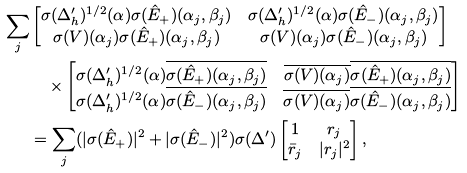Convert formula to latex. <formula><loc_0><loc_0><loc_500><loc_500>\sum _ { j } & \begin{bmatrix} \sigma ( \Delta ^ { \prime } _ { h } ) ^ { 1 / 2 } ( \alpha ) \sigma ( \hat { E } _ { + } ) ( \alpha _ { j } , \beta _ { j } ) & \sigma ( \Delta ^ { \prime } _ { h } ) ^ { 1 / 2 } ( \alpha ) \sigma ( \hat { E } _ { - } ) ( \alpha _ { j } , \beta _ { j } ) \\ \sigma ( V ) ( \alpha _ { j } ) \sigma ( \hat { E } _ { + } ) ( \alpha _ { j } , \beta _ { j } ) & \sigma ( V ) ( \alpha _ { j } ) \sigma ( \hat { E } _ { - } ) ( \alpha _ { j } , \beta _ { j } ) \end{bmatrix} \\ & \quad \times \begin{bmatrix} \sigma ( \Delta ^ { \prime } _ { h } ) ^ { 1 / 2 } ( \alpha ) \overline { \sigma ( \hat { E } _ { + } ) ( \alpha _ { j } , \beta _ { j } ) } & \overline { \sigma ( V ) ( \alpha _ { j } ) } \overline { \sigma ( \hat { E } _ { + } ) ( \alpha _ { j } , \beta _ { j } ) } \\ \sigma ( \Delta ^ { \prime } _ { h } ) ^ { 1 / 2 } ( \alpha ) \overline { \sigma ( \hat { E } _ { - } ) ( \alpha _ { j } , \beta _ { j } ) } & \overline { \sigma ( V ) ( \alpha _ { j } ) } \overline { \sigma ( \hat { E } _ { - } ) ( \alpha _ { j } , \beta _ { j } ) } \end{bmatrix} \\ & = \sum _ { j } ( | \sigma ( \hat { E } _ { + } ) | ^ { 2 } + | \sigma ( \hat { E } _ { - } ) | ^ { 2 } ) \sigma ( \Delta ^ { \prime } ) \begin{bmatrix} 1 & r _ { j } \\ \bar { r } _ { j } & | r _ { j } | ^ { 2 } \end{bmatrix} ,</formula> 